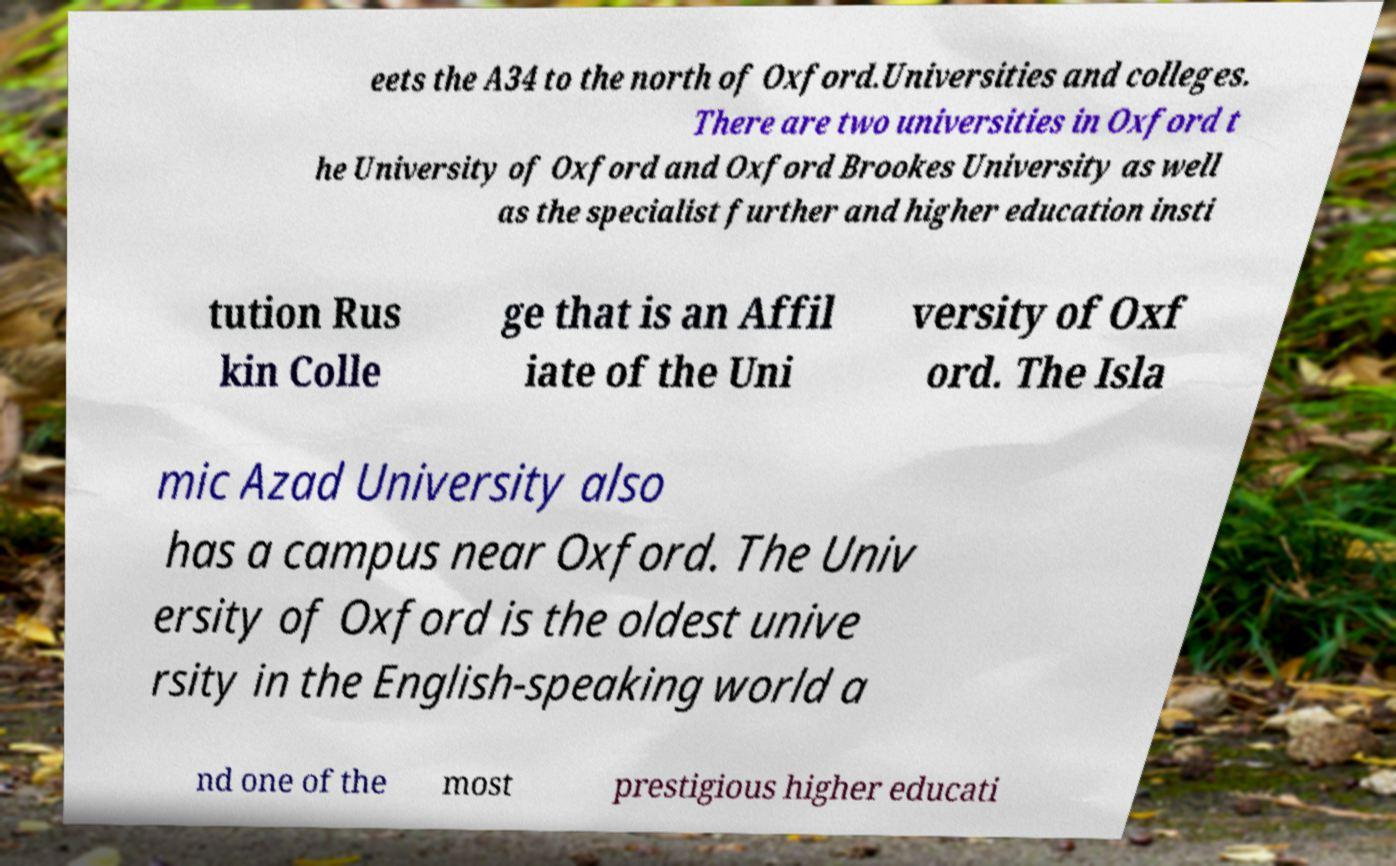Can you read and provide the text displayed in the image?This photo seems to have some interesting text. Can you extract and type it out for me? eets the A34 to the north of Oxford.Universities and colleges. There are two universities in Oxford t he University of Oxford and Oxford Brookes University as well as the specialist further and higher education insti tution Rus kin Colle ge that is an Affil iate of the Uni versity of Oxf ord. The Isla mic Azad University also has a campus near Oxford. The Univ ersity of Oxford is the oldest unive rsity in the English-speaking world a nd one of the most prestigious higher educati 